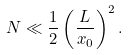Convert formula to latex. <formula><loc_0><loc_0><loc_500><loc_500>N \ll \frac { 1 } { 2 } \left ( \frac { L } { x _ { 0 } } \right ) ^ { 2 } .</formula> 